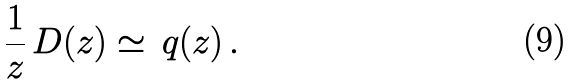<formula> <loc_0><loc_0><loc_500><loc_500>\frac { 1 } { z } \, D ( z ) \simeq \, q ( z ) \, .</formula> 